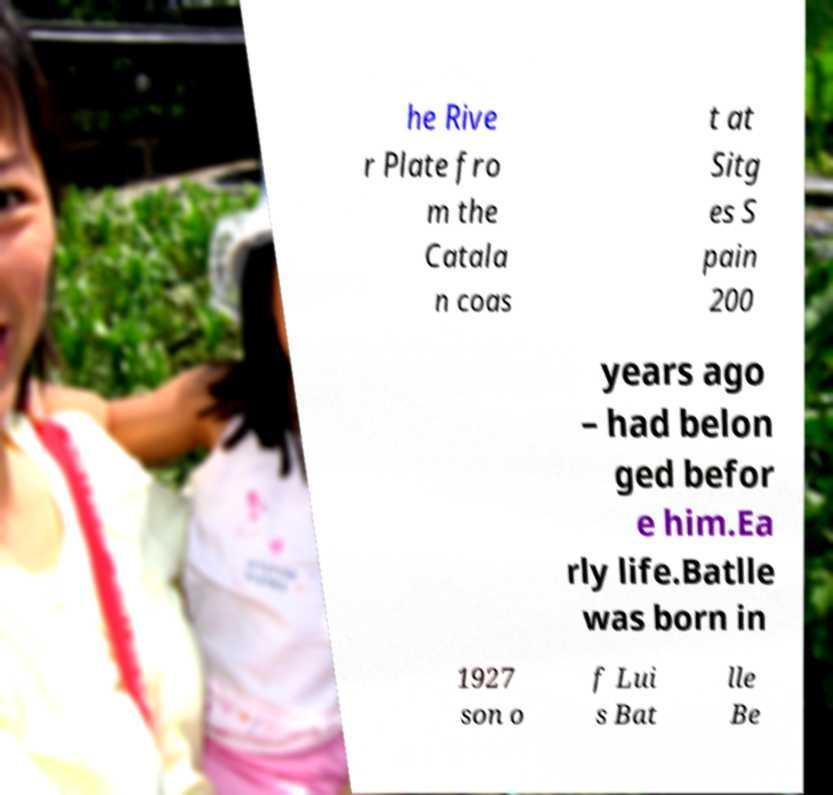Can you read and provide the text displayed in the image?This photo seems to have some interesting text. Can you extract and type it out for me? he Rive r Plate fro m the Catala n coas t at Sitg es S pain 200 years ago – had belon ged befor e him.Ea rly life.Batlle was born in 1927 son o f Lui s Bat lle Be 